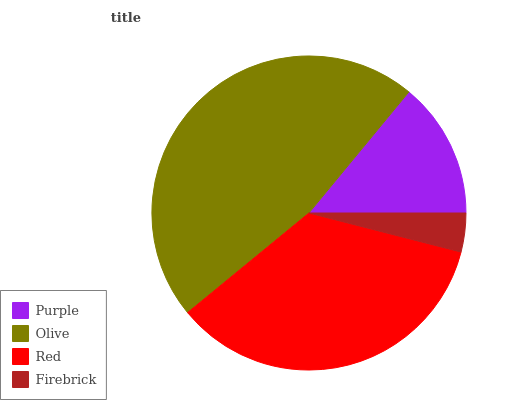Is Firebrick the minimum?
Answer yes or no. Yes. Is Olive the maximum?
Answer yes or no. Yes. Is Red the minimum?
Answer yes or no. No. Is Red the maximum?
Answer yes or no. No. Is Olive greater than Red?
Answer yes or no. Yes. Is Red less than Olive?
Answer yes or no. Yes. Is Red greater than Olive?
Answer yes or no. No. Is Olive less than Red?
Answer yes or no. No. Is Red the high median?
Answer yes or no. Yes. Is Purple the low median?
Answer yes or no. Yes. Is Firebrick the high median?
Answer yes or no. No. Is Olive the low median?
Answer yes or no. No. 